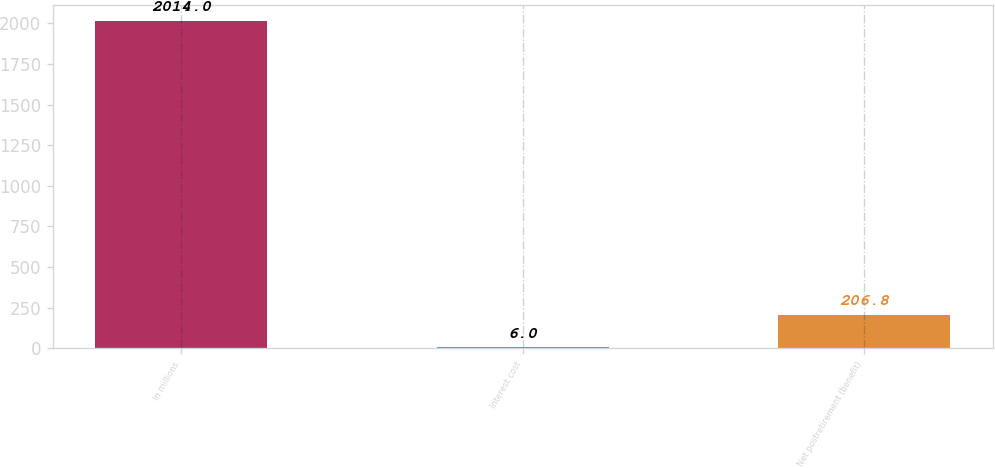Convert chart to OTSL. <chart><loc_0><loc_0><loc_500><loc_500><bar_chart><fcel>In millions<fcel>Interest cost<fcel>Net postretirement (benefit)<nl><fcel>2014<fcel>6<fcel>206.8<nl></chart> 